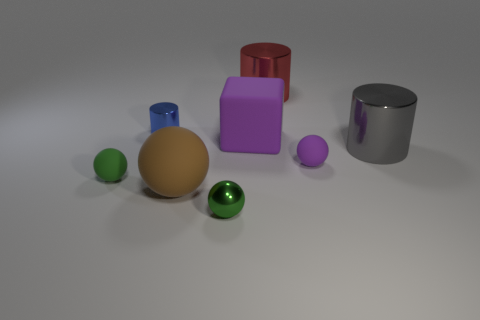Add 1 big purple matte blocks. How many objects exist? 9 Subtract all cylinders. How many objects are left? 5 Subtract 1 purple balls. How many objects are left? 7 Subtract all big red cylinders. Subtract all big purple rubber cubes. How many objects are left? 6 Add 5 large cylinders. How many large cylinders are left? 7 Add 8 big gray cylinders. How many big gray cylinders exist? 9 